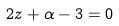Convert formula to latex. <formula><loc_0><loc_0><loc_500><loc_500>2 z + \alpha - 3 = 0</formula> 